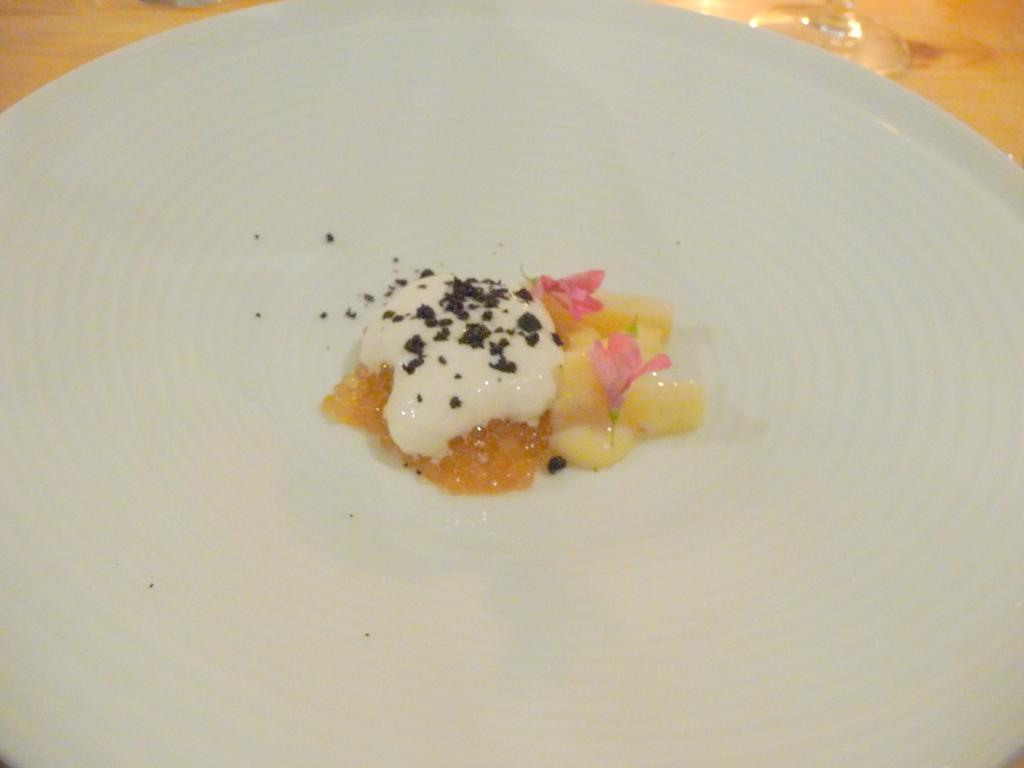What is on the plate that is visible in the image? There is a plate with food items in the image. What type of container is present in the image? There is a glass in the image. What material is the surface visible in the image? The wooden surface is visible in the image. Can you see the stomach of the person eating the food in the image? There is no person visible in the image, so it is not possible to see their stomach. 